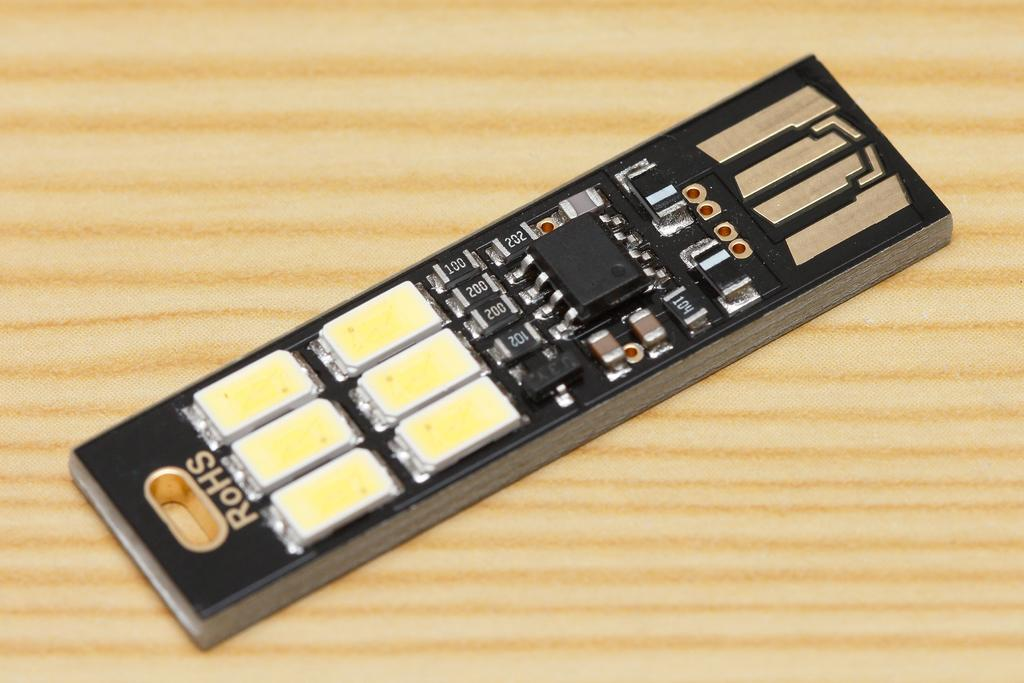<image>
Give a short and clear explanation of the subsequent image. A black and yellow small electric component made by RoHs. 